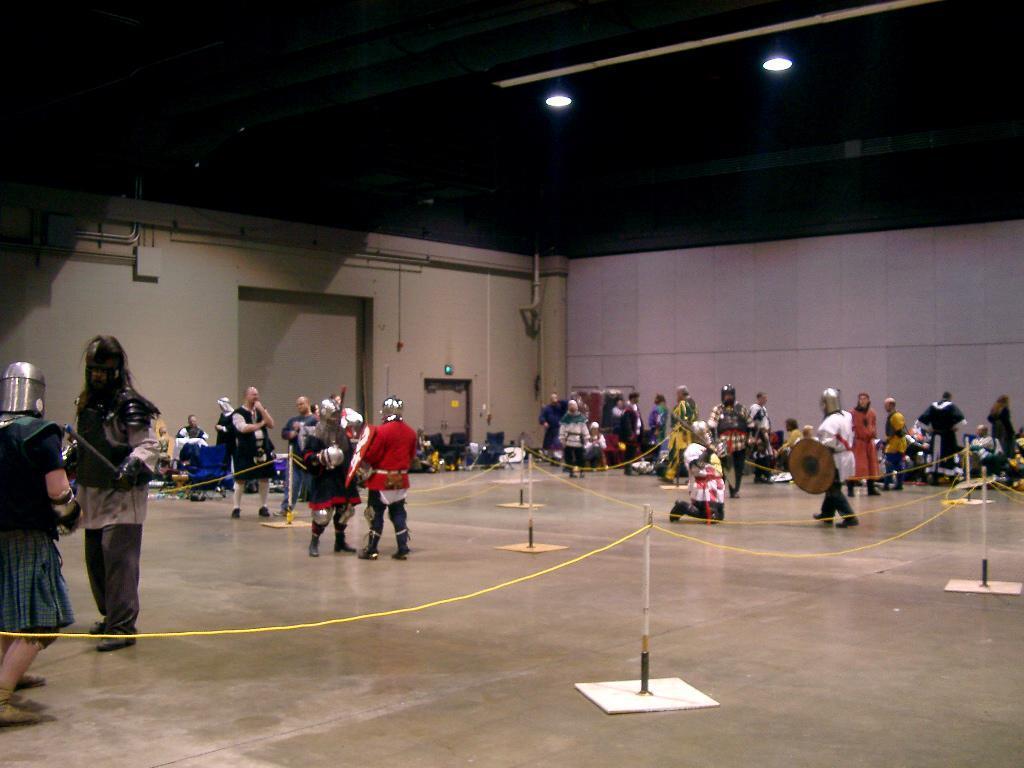Describe this image in one or two sentences. In this image, we can see people, rod stands, ropes and floor. Background we can see walls, pipes, door and few objects. Top of the image, we can see the lights and pipes. 